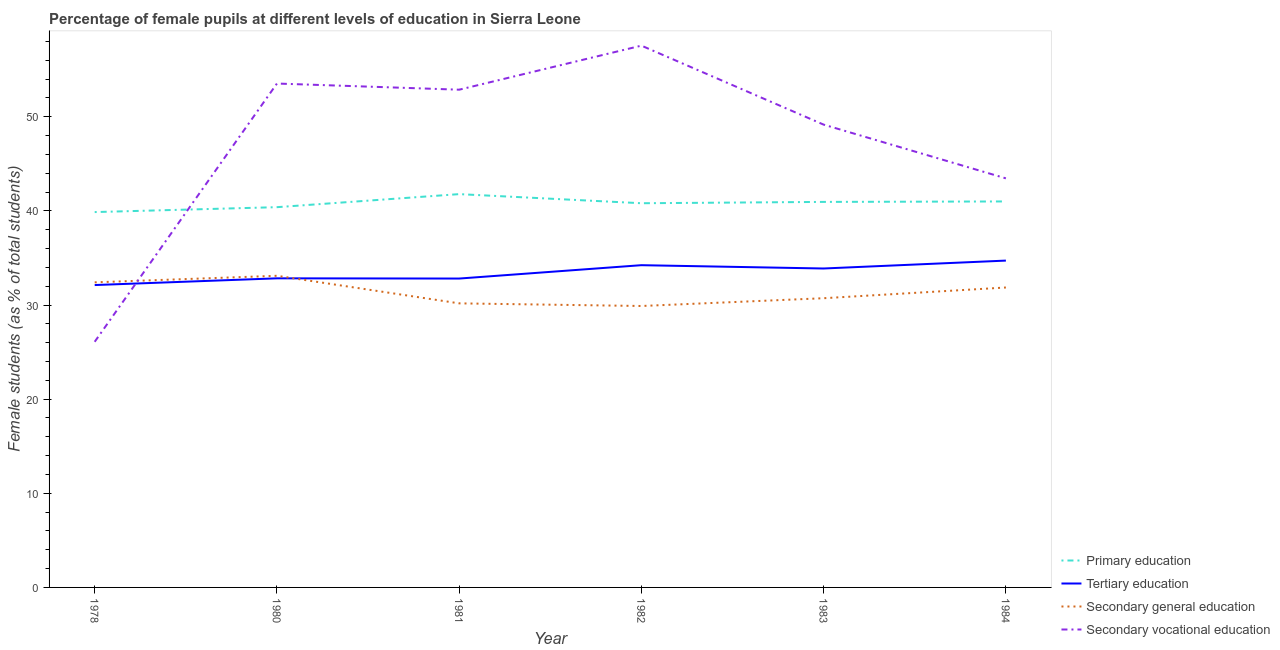Is the number of lines equal to the number of legend labels?
Make the answer very short. Yes. What is the percentage of female students in tertiary education in 1978?
Ensure brevity in your answer.  32.12. Across all years, what is the maximum percentage of female students in primary education?
Your answer should be very brief. 41.78. Across all years, what is the minimum percentage of female students in secondary vocational education?
Provide a succinct answer. 26.09. In which year was the percentage of female students in primary education minimum?
Your answer should be compact. 1978. What is the total percentage of female students in tertiary education in the graph?
Give a very brief answer. 200.59. What is the difference between the percentage of female students in primary education in 1978 and that in 1984?
Keep it short and to the point. -1.13. What is the difference between the percentage of female students in primary education in 1981 and the percentage of female students in tertiary education in 1980?
Provide a short and direct response. 8.95. What is the average percentage of female students in secondary vocational education per year?
Offer a very short reply. 47.11. In the year 1984, what is the difference between the percentage of female students in secondary education and percentage of female students in tertiary education?
Your answer should be compact. -2.86. What is the ratio of the percentage of female students in primary education in 1982 to that in 1983?
Your answer should be very brief. 1. What is the difference between the highest and the second highest percentage of female students in tertiary education?
Offer a terse response. 0.49. What is the difference between the highest and the lowest percentage of female students in secondary vocational education?
Your answer should be compact. 31.46. In how many years, is the percentage of female students in secondary vocational education greater than the average percentage of female students in secondary vocational education taken over all years?
Keep it short and to the point. 4. Is the sum of the percentage of female students in tertiary education in 1978 and 1982 greater than the maximum percentage of female students in primary education across all years?
Provide a succinct answer. Yes. Is the percentage of female students in primary education strictly less than the percentage of female students in tertiary education over the years?
Ensure brevity in your answer.  No. Does the graph contain grids?
Provide a short and direct response. No. How many legend labels are there?
Provide a short and direct response. 4. How are the legend labels stacked?
Your answer should be very brief. Vertical. What is the title of the graph?
Keep it short and to the point. Percentage of female pupils at different levels of education in Sierra Leone. What is the label or title of the X-axis?
Your response must be concise. Year. What is the label or title of the Y-axis?
Offer a terse response. Female students (as % of total students). What is the Female students (as % of total students) of Primary education in 1978?
Provide a short and direct response. 39.87. What is the Female students (as % of total students) in Tertiary education in 1978?
Provide a short and direct response. 32.12. What is the Female students (as % of total students) of Secondary general education in 1978?
Provide a succinct answer. 32.41. What is the Female students (as % of total students) of Secondary vocational education in 1978?
Offer a terse response. 26.09. What is the Female students (as % of total students) of Primary education in 1980?
Keep it short and to the point. 40.39. What is the Female students (as % of total students) in Tertiary education in 1980?
Your answer should be compact. 32.83. What is the Female students (as % of total students) of Secondary general education in 1980?
Provide a succinct answer. 33.1. What is the Female students (as % of total students) in Secondary vocational education in 1980?
Make the answer very short. 53.52. What is the Female students (as % of total students) in Primary education in 1981?
Make the answer very short. 41.78. What is the Female students (as % of total students) of Tertiary education in 1981?
Provide a succinct answer. 32.81. What is the Female students (as % of total students) in Secondary general education in 1981?
Provide a short and direct response. 30.17. What is the Female students (as % of total students) of Secondary vocational education in 1981?
Your response must be concise. 52.87. What is the Female students (as % of total students) in Primary education in 1982?
Provide a succinct answer. 40.81. What is the Female students (as % of total students) in Tertiary education in 1982?
Ensure brevity in your answer.  34.23. What is the Female students (as % of total students) in Secondary general education in 1982?
Offer a terse response. 29.89. What is the Female students (as % of total students) of Secondary vocational education in 1982?
Your response must be concise. 57.55. What is the Female students (as % of total students) of Primary education in 1983?
Provide a short and direct response. 40.95. What is the Female students (as % of total students) of Tertiary education in 1983?
Offer a very short reply. 33.88. What is the Female students (as % of total students) in Secondary general education in 1983?
Your answer should be very brief. 30.72. What is the Female students (as % of total students) of Secondary vocational education in 1983?
Provide a succinct answer. 49.16. What is the Female students (as % of total students) in Primary education in 1984?
Keep it short and to the point. 41. What is the Female students (as % of total students) in Tertiary education in 1984?
Keep it short and to the point. 34.72. What is the Female students (as % of total students) in Secondary general education in 1984?
Provide a short and direct response. 31.86. What is the Female students (as % of total students) in Secondary vocational education in 1984?
Keep it short and to the point. 43.45. Across all years, what is the maximum Female students (as % of total students) in Primary education?
Your answer should be compact. 41.78. Across all years, what is the maximum Female students (as % of total students) in Tertiary education?
Offer a very short reply. 34.72. Across all years, what is the maximum Female students (as % of total students) of Secondary general education?
Keep it short and to the point. 33.1. Across all years, what is the maximum Female students (as % of total students) in Secondary vocational education?
Your response must be concise. 57.55. Across all years, what is the minimum Female students (as % of total students) in Primary education?
Keep it short and to the point. 39.87. Across all years, what is the minimum Female students (as % of total students) of Tertiary education?
Your response must be concise. 32.12. Across all years, what is the minimum Female students (as % of total students) of Secondary general education?
Ensure brevity in your answer.  29.89. Across all years, what is the minimum Female students (as % of total students) of Secondary vocational education?
Make the answer very short. 26.09. What is the total Female students (as % of total students) in Primary education in the graph?
Keep it short and to the point. 244.8. What is the total Female students (as % of total students) in Tertiary education in the graph?
Your answer should be compact. 200.59. What is the total Female students (as % of total students) in Secondary general education in the graph?
Your answer should be very brief. 188.16. What is the total Female students (as % of total students) of Secondary vocational education in the graph?
Ensure brevity in your answer.  282.65. What is the difference between the Female students (as % of total students) in Primary education in 1978 and that in 1980?
Provide a short and direct response. -0.52. What is the difference between the Female students (as % of total students) in Tertiary education in 1978 and that in 1980?
Your response must be concise. -0.71. What is the difference between the Female students (as % of total students) of Secondary general education in 1978 and that in 1980?
Ensure brevity in your answer.  -0.7. What is the difference between the Female students (as % of total students) of Secondary vocational education in 1978 and that in 1980?
Ensure brevity in your answer.  -27.43. What is the difference between the Female students (as % of total students) of Primary education in 1978 and that in 1981?
Provide a succinct answer. -1.91. What is the difference between the Female students (as % of total students) of Tertiary education in 1978 and that in 1981?
Your response must be concise. -0.69. What is the difference between the Female students (as % of total students) in Secondary general education in 1978 and that in 1981?
Ensure brevity in your answer.  2.23. What is the difference between the Female students (as % of total students) of Secondary vocational education in 1978 and that in 1981?
Keep it short and to the point. -26.78. What is the difference between the Female students (as % of total students) of Primary education in 1978 and that in 1982?
Offer a terse response. -0.94. What is the difference between the Female students (as % of total students) in Tertiary education in 1978 and that in 1982?
Provide a short and direct response. -2.11. What is the difference between the Female students (as % of total students) of Secondary general education in 1978 and that in 1982?
Offer a very short reply. 2.51. What is the difference between the Female students (as % of total students) in Secondary vocational education in 1978 and that in 1982?
Your answer should be compact. -31.46. What is the difference between the Female students (as % of total students) of Primary education in 1978 and that in 1983?
Your response must be concise. -1.08. What is the difference between the Female students (as % of total students) of Tertiary education in 1978 and that in 1983?
Ensure brevity in your answer.  -1.76. What is the difference between the Female students (as % of total students) in Secondary general education in 1978 and that in 1983?
Give a very brief answer. 1.69. What is the difference between the Female students (as % of total students) of Secondary vocational education in 1978 and that in 1983?
Make the answer very short. -23.07. What is the difference between the Female students (as % of total students) of Primary education in 1978 and that in 1984?
Offer a very short reply. -1.13. What is the difference between the Female students (as % of total students) in Tertiary education in 1978 and that in 1984?
Keep it short and to the point. -2.6. What is the difference between the Female students (as % of total students) of Secondary general education in 1978 and that in 1984?
Your answer should be compact. 0.55. What is the difference between the Female students (as % of total students) in Secondary vocational education in 1978 and that in 1984?
Ensure brevity in your answer.  -17.36. What is the difference between the Female students (as % of total students) of Primary education in 1980 and that in 1981?
Give a very brief answer. -1.39. What is the difference between the Female students (as % of total students) in Tertiary education in 1980 and that in 1981?
Give a very brief answer. 0.02. What is the difference between the Female students (as % of total students) in Secondary general education in 1980 and that in 1981?
Your answer should be compact. 2.93. What is the difference between the Female students (as % of total students) of Secondary vocational education in 1980 and that in 1981?
Ensure brevity in your answer.  0.65. What is the difference between the Female students (as % of total students) of Primary education in 1980 and that in 1982?
Give a very brief answer. -0.42. What is the difference between the Female students (as % of total students) of Tertiary education in 1980 and that in 1982?
Provide a short and direct response. -1.4. What is the difference between the Female students (as % of total students) in Secondary general education in 1980 and that in 1982?
Your response must be concise. 3.21. What is the difference between the Female students (as % of total students) of Secondary vocational education in 1980 and that in 1982?
Offer a very short reply. -4.03. What is the difference between the Female students (as % of total students) in Primary education in 1980 and that in 1983?
Offer a very short reply. -0.56. What is the difference between the Female students (as % of total students) in Tertiary education in 1980 and that in 1983?
Offer a terse response. -1.05. What is the difference between the Female students (as % of total students) in Secondary general education in 1980 and that in 1983?
Keep it short and to the point. 2.38. What is the difference between the Female students (as % of total students) in Secondary vocational education in 1980 and that in 1983?
Your response must be concise. 4.37. What is the difference between the Female students (as % of total students) in Primary education in 1980 and that in 1984?
Give a very brief answer. -0.61. What is the difference between the Female students (as % of total students) of Tertiary education in 1980 and that in 1984?
Provide a short and direct response. -1.88. What is the difference between the Female students (as % of total students) in Secondary general education in 1980 and that in 1984?
Offer a terse response. 1.24. What is the difference between the Female students (as % of total students) of Secondary vocational education in 1980 and that in 1984?
Give a very brief answer. 10.07. What is the difference between the Female students (as % of total students) in Primary education in 1981 and that in 1982?
Provide a succinct answer. 0.97. What is the difference between the Female students (as % of total students) of Tertiary education in 1981 and that in 1982?
Your answer should be very brief. -1.42. What is the difference between the Female students (as % of total students) of Secondary general education in 1981 and that in 1982?
Provide a short and direct response. 0.28. What is the difference between the Female students (as % of total students) in Secondary vocational education in 1981 and that in 1982?
Your answer should be compact. -4.68. What is the difference between the Female students (as % of total students) in Primary education in 1981 and that in 1983?
Your answer should be compact. 0.83. What is the difference between the Female students (as % of total students) in Tertiary education in 1981 and that in 1983?
Your answer should be very brief. -1.07. What is the difference between the Female students (as % of total students) in Secondary general education in 1981 and that in 1983?
Offer a very short reply. -0.55. What is the difference between the Female students (as % of total students) of Secondary vocational education in 1981 and that in 1983?
Offer a very short reply. 3.71. What is the difference between the Female students (as % of total students) of Primary education in 1981 and that in 1984?
Your answer should be compact. 0.78. What is the difference between the Female students (as % of total students) in Tertiary education in 1981 and that in 1984?
Your answer should be compact. -1.91. What is the difference between the Female students (as % of total students) of Secondary general education in 1981 and that in 1984?
Your response must be concise. -1.68. What is the difference between the Female students (as % of total students) of Secondary vocational education in 1981 and that in 1984?
Offer a terse response. 9.42. What is the difference between the Female students (as % of total students) of Primary education in 1982 and that in 1983?
Provide a short and direct response. -0.14. What is the difference between the Female students (as % of total students) in Tertiary education in 1982 and that in 1983?
Your response must be concise. 0.35. What is the difference between the Female students (as % of total students) of Secondary general education in 1982 and that in 1983?
Keep it short and to the point. -0.83. What is the difference between the Female students (as % of total students) of Secondary vocational education in 1982 and that in 1983?
Provide a short and direct response. 8.39. What is the difference between the Female students (as % of total students) in Primary education in 1982 and that in 1984?
Offer a terse response. -0.19. What is the difference between the Female students (as % of total students) of Tertiary education in 1982 and that in 1984?
Your answer should be compact. -0.49. What is the difference between the Female students (as % of total students) of Secondary general education in 1982 and that in 1984?
Provide a succinct answer. -1.97. What is the difference between the Female students (as % of total students) in Secondary vocational education in 1982 and that in 1984?
Provide a succinct answer. 14.1. What is the difference between the Female students (as % of total students) in Primary education in 1983 and that in 1984?
Offer a very short reply. -0.05. What is the difference between the Female students (as % of total students) in Tertiary education in 1983 and that in 1984?
Your answer should be very brief. -0.84. What is the difference between the Female students (as % of total students) of Secondary general education in 1983 and that in 1984?
Make the answer very short. -1.14. What is the difference between the Female students (as % of total students) of Secondary vocational education in 1983 and that in 1984?
Offer a terse response. 5.71. What is the difference between the Female students (as % of total students) in Primary education in 1978 and the Female students (as % of total students) in Tertiary education in 1980?
Provide a short and direct response. 7.04. What is the difference between the Female students (as % of total students) in Primary education in 1978 and the Female students (as % of total students) in Secondary general education in 1980?
Your response must be concise. 6.77. What is the difference between the Female students (as % of total students) of Primary education in 1978 and the Female students (as % of total students) of Secondary vocational education in 1980?
Provide a succinct answer. -13.65. What is the difference between the Female students (as % of total students) of Tertiary education in 1978 and the Female students (as % of total students) of Secondary general education in 1980?
Your response must be concise. -0.98. What is the difference between the Female students (as % of total students) in Tertiary education in 1978 and the Female students (as % of total students) in Secondary vocational education in 1980?
Give a very brief answer. -21.41. What is the difference between the Female students (as % of total students) of Secondary general education in 1978 and the Female students (as % of total students) of Secondary vocational education in 1980?
Ensure brevity in your answer.  -21.12. What is the difference between the Female students (as % of total students) of Primary education in 1978 and the Female students (as % of total students) of Tertiary education in 1981?
Your answer should be very brief. 7.06. What is the difference between the Female students (as % of total students) in Primary education in 1978 and the Female students (as % of total students) in Secondary general education in 1981?
Provide a short and direct response. 9.7. What is the difference between the Female students (as % of total students) in Primary education in 1978 and the Female students (as % of total students) in Secondary vocational education in 1981?
Your response must be concise. -13. What is the difference between the Female students (as % of total students) of Tertiary education in 1978 and the Female students (as % of total students) of Secondary general education in 1981?
Your answer should be compact. 1.94. What is the difference between the Female students (as % of total students) in Tertiary education in 1978 and the Female students (as % of total students) in Secondary vocational education in 1981?
Provide a short and direct response. -20.75. What is the difference between the Female students (as % of total students) of Secondary general education in 1978 and the Female students (as % of total students) of Secondary vocational education in 1981?
Make the answer very short. -20.46. What is the difference between the Female students (as % of total students) of Primary education in 1978 and the Female students (as % of total students) of Tertiary education in 1982?
Offer a very short reply. 5.64. What is the difference between the Female students (as % of total students) of Primary education in 1978 and the Female students (as % of total students) of Secondary general education in 1982?
Offer a very short reply. 9.98. What is the difference between the Female students (as % of total students) in Primary education in 1978 and the Female students (as % of total students) in Secondary vocational education in 1982?
Your answer should be compact. -17.68. What is the difference between the Female students (as % of total students) of Tertiary education in 1978 and the Female students (as % of total students) of Secondary general education in 1982?
Keep it short and to the point. 2.22. What is the difference between the Female students (as % of total students) in Tertiary education in 1978 and the Female students (as % of total students) in Secondary vocational education in 1982?
Make the answer very short. -25.43. What is the difference between the Female students (as % of total students) in Secondary general education in 1978 and the Female students (as % of total students) in Secondary vocational education in 1982?
Offer a very short reply. -25.14. What is the difference between the Female students (as % of total students) of Primary education in 1978 and the Female students (as % of total students) of Tertiary education in 1983?
Make the answer very short. 5.99. What is the difference between the Female students (as % of total students) of Primary education in 1978 and the Female students (as % of total students) of Secondary general education in 1983?
Provide a succinct answer. 9.15. What is the difference between the Female students (as % of total students) of Primary education in 1978 and the Female students (as % of total students) of Secondary vocational education in 1983?
Provide a short and direct response. -9.29. What is the difference between the Female students (as % of total students) of Tertiary education in 1978 and the Female students (as % of total students) of Secondary general education in 1983?
Give a very brief answer. 1.4. What is the difference between the Female students (as % of total students) in Tertiary education in 1978 and the Female students (as % of total students) in Secondary vocational education in 1983?
Offer a very short reply. -17.04. What is the difference between the Female students (as % of total students) of Secondary general education in 1978 and the Female students (as % of total students) of Secondary vocational education in 1983?
Provide a short and direct response. -16.75. What is the difference between the Female students (as % of total students) in Primary education in 1978 and the Female students (as % of total students) in Tertiary education in 1984?
Offer a very short reply. 5.15. What is the difference between the Female students (as % of total students) in Primary education in 1978 and the Female students (as % of total students) in Secondary general education in 1984?
Make the answer very short. 8.01. What is the difference between the Female students (as % of total students) in Primary education in 1978 and the Female students (as % of total students) in Secondary vocational education in 1984?
Your response must be concise. -3.58. What is the difference between the Female students (as % of total students) in Tertiary education in 1978 and the Female students (as % of total students) in Secondary general education in 1984?
Provide a short and direct response. 0.26. What is the difference between the Female students (as % of total students) of Tertiary education in 1978 and the Female students (as % of total students) of Secondary vocational education in 1984?
Your answer should be very brief. -11.33. What is the difference between the Female students (as % of total students) in Secondary general education in 1978 and the Female students (as % of total students) in Secondary vocational education in 1984?
Ensure brevity in your answer.  -11.04. What is the difference between the Female students (as % of total students) in Primary education in 1980 and the Female students (as % of total students) in Tertiary education in 1981?
Offer a very short reply. 7.58. What is the difference between the Female students (as % of total students) in Primary education in 1980 and the Female students (as % of total students) in Secondary general education in 1981?
Offer a terse response. 10.22. What is the difference between the Female students (as % of total students) in Primary education in 1980 and the Female students (as % of total students) in Secondary vocational education in 1981?
Your response must be concise. -12.48. What is the difference between the Female students (as % of total students) in Tertiary education in 1980 and the Female students (as % of total students) in Secondary general education in 1981?
Your response must be concise. 2.66. What is the difference between the Female students (as % of total students) of Tertiary education in 1980 and the Female students (as % of total students) of Secondary vocational education in 1981?
Your answer should be very brief. -20.04. What is the difference between the Female students (as % of total students) in Secondary general education in 1980 and the Female students (as % of total students) in Secondary vocational education in 1981?
Give a very brief answer. -19.77. What is the difference between the Female students (as % of total students) of Primary education in 1980 and the Female students (as % of total students) of Tertiary education in 1982?
Offer a terse response. 6.16. What is the difference between the Female students (as % of total students) of Primary education in 1980 and the Female students (as % of total students) of Secondary general education in 1982?
Ensure brevity in your answer.  10.5. What is the difference between the Female students (as % of total students) in Primary education in 1980 and the Female students (as % of total students) in Secondary vocational education in 1982?
Keep it short and to the point. -17.16. What is the difference between the Female students (as % of total students) in Tertiary education in 1980 and the Female students (as % of total students) in Secondary general education in 1982?
Ensure brevity in your answer.  2.94. What is the difference between the Female students (as % of total students) of Tertiary education in 1980 and the Female students (as % of total students) of Secondary vocational education in 1982?
Your response must be concise. -24.72. What is the difference between the Female students (as % of total students) of Secondary general education in 1980 and the Female students (as % of total students) of Secondary vocational education in 1982?
Ensure brevity in your answer.  -24.45. What is the difference between the Female students (as % of total students) in Primary education in 1980 and the Female students (as % of total students) in Tertiary education in 1983?
Your answer should be very brief. 6.51. What is the difference between the Female students (as % of total students) in Primary education in 1980 and the Female students (as % of total students) in Secondary general education in 1983?
Offer a very short reply. 9.67. What is the difference between the Female students (as % of total students) in Primary education in 1980 and the Female students (as % of total students) in Secondary vocational education in 1983?
Your answer should be compact. -8.77. What is the difference between the Female students (as % of total students) in Tertiary education in 1980 and the Female students (as % of total students) in Secondary general education in 1983?
Give a very brief answer. 2.11. What is the difference between the Female students (as % of total students) in Tertiary education in 1980 and the Female students (as % of total students) in Secondary vocational education in 1983?
Keep it short and to the point. -16.33. What is the difference between the Female students (as % of total students) of Secondary general education in 1980 and the Female students (as % of total students) of Secondary vocational education in 1983?
Provide a short and direct response. -16.06. What is the difference between the Female students (as % of total students) in Primary education in 1980 and the Female students (as % of total students) in Tertiary education in 1984?
Provide a short and direct response. 5.67. What is the difference between the Female students (as % of total students) in Primary education in 1980 and the Female students (as % of total students) in Secondary general education in 1984?
Your response must be concise. 8.53. What is the difference between the Female students (as % of total students) of Primary education in 1980 and the Female students (as % of total students) of Secondary vocational education in 1984?
Your response must be concise. -3.06. What is the difference between the Female students (as % of total students) in Tertiary education in 1980 and the Female students (as % of total students) in Secondary general education in 1984?
Your answer should be compact. 0.97. What is the difference between the Female students (as % of total students) of Tertiary education in 1980 and the Female students (as % of total students) of Secondary vocational education in 1984?
Make the answer very short. -10.62. What is the difference between the Female students (as % of total students) in Secondary general education in 1980 and the Female students (as % of total students) in Secondary vocational education in 1984?
Offer a very short reply. -10.35. What is the difference between the Female students (as % of total students) in Primary education in 1981 and the Female students (as % of total students) in Tertiary education in 1982?
Your response must be concise. 7.55. What is the difference between the Female students (as % of total students) in Primary education in 1981 and the Female students (as % of total students) in Secondary general education in 1982?
Provide a succinct answer. 11.88. What is the difference between the Female students (as % of total students) in Primary education in 1981 and the Female students (as % of total students) in Secondary vocational education in 1982?
Your answer should be very brief. -15.77. What is the difference between the Female students (as % of total students) of Tertiary education in 1981 and the Female students (as % of total students) of Secondary general education in 1982?
Keep it short and to the point. 2.92. What is the difference between the Female students (as % of total students) in Tertiary education in 1981 and the Female students (as % of total students) in Secondary vocational education in 1982?
Ensure brevity in your answer.  -24.74. What is the difference between the Female students (as % of total students) of Secondary general education in 1981 and the Female students (as % of total students) of Secondary vocational education in 1982?
Offer a terse response. -27.38. What is the difference between the Female students (as % of total students) of Primary education in 1981 and the Female students (as % of total students) of Tertiary education in 1983?
Provide a succinct answer. 7.9. What is the difference between the Female students (as % of total students) in Primary education in 1981 and the Female students (as % of total students) in Secondary general education in 1983?
Your answer should be very brief. 11.06. What is the difference between the Female students (as % of total students) of Primary education in 1981 and the Female students (as % of total students) of Secondary vocational education in 1983?
Offer a terse response. -7.38. What is the difference between the Female students (as % of total students) in Tertiary education in 1981 and the Female students (as % of total students) in Secondary general education in 1983?
Give a very brief answer. 2.09. What is the difference between the Female students (as % of total students) in Tertiary education in 1981 and the Female students (as % of total students) in Secondary vocational education in 1983?
Your answer should be very brief. -16.35. What is the difference between the Female students (as % of total students) in Secondary general education in 1981 and the Female students (as % of total students) in Secondary vocational education in 1983?
Ensure brevity in your answer.  -18.98. What is the difference between the Female students (as % of total students) of Primary education in 1981 and the Female students (as % of total students) of Tertiary education in 1984?
Provide a succinct answer. 7.06. What is the difference between the Female students (as % of total students) of Primary education in 1981 and the Female students (as % of total students) of Secondary general education in 1984?
Provide a succinct answer. 9.92. What is the difference between the Female students (as % of total students) of Primary education in 1981 and the Female students (as % of total students) of Secondary vocational education in 1984?
Your answer should be compact. -1.67. What is the difference between the Female students (as % of total students) of Tertiary education in 1981 and the Female students (as % of total students) of Secondary vocational education in 1984?
Keep it short and to the point. -10.64. What is the difference between the Female students (as % of total students) in Secondary general education in 1981 and the Female students (as % of total students) in Secondary vocational education in 1984?
Give a very brief answer. -13.28. What is the difference between the Female students (as % of total students) in Primary education in 1982 and the Female students (as % of total students) in Tertiary education in 1983?
Keep it short and to the point. 6.93. What is the difference between the Female students (as % of total students) of Primary education in 1982 and the Female students (as % of total students) of Secondary general education in 1983?
Offer a terse response. 10.09. What is the difference between the Female students (as % of total students) of Primary education in 1982 and the Female students (as % of total students) of Secondary vocational education in 1983?
Provide a succinct answer. -8.35. What is the difference between the Female students (as % of total students) in Tertiary education in 1982 and the Female students (as % of total students) in Secondary general education in 1983?
Provide a succinct answer. 3.51. What is the difference between the Female students (as % of total students) in Tertiary education in 1982 and the Female students (as % of total students) in Secondary vocational education in 1983?
Keep it short and to the point. -14.93. What is the difference between the Female students (as % of total students) of Secondary general education in 1982 and the Female students (as % of total students) of Secondary vocational education in 1983?
Your response must be concise. -19.26. What is the difference between the Female students (as % of total students) of Primary education in 1982 and the Female students (as % of total students) of Tertiary education in 1984?
Provide a short and direct response. 6.09. What is the difference between the Female students (as % of total students) of Primary education in 1982 and the Female students (as % of total students) of Secondary general education in 1984?
Offer a terse response. 8.95. What is the difference between the Female students (as % of total students) of Primary education in 1982 and the Female students (as % of total students) of Secondary vocational education in 1984?
Provide a short and direct response. -2.64. What is the difference between the Female students (as % of total students) of Tertiary education in 1982 and the Female students (as % of total students) of Secondary general education in 1984?
Keep it short and to the point. 2.37. What is the difference between the Female students (as % of total students) of Tertiary education in 1982 and the Female students (as % of total students) of Secondary vocational education in 1984?
Offer a very short reply. -9.22. What is the difference between the Female students (as % of total students) of Secondary general education in 1982 and the Female students (as % of total students) of Secondary vocational education in 1984?
Offer a very short reply. -13.56. What is the difference between the Female students (as % of total students) of Primary education in 1983 and the Female students (as % of total students) of Tertiary education in 1984?
Provide a succinct answer. 6.23. What is the difference between the Female students (as % of total students) of Primary education in 1983 and the Female students (as % of total students) of Secondary general education in 1984?
Keep it short and to the point. 9.09. What is the difference between the Female students (as % of total students) in Primary education in 1983 and the Female students (as % of total students) in Secondary vocational education in 1984?
Keep it short and to the point. -2.5. What is the difference between the Female students (as % of total students) in Tertiary education in 1983 and the Female students (as % of total students) in Secondary general education in 1984?
Your response must be concise. 2.02. What is the difference between the Female students (as % of total students) of Tertiary education in 1983 and the Female students (as % of total students) of Secondary vocational education in 1984?
Ensure brevity in your answer.  -9.57. What is the difference between the Female students (as % of total students) of Secondary general education in 1983 and the Female students (as % of total students) of Secondary vocational education in 1984?
Provide a succinct answer. -12.73. What is the average Female students (as % of total students) of Primary education per year?
Ensure brevity in your answer.  40.8. What is the average Female students (as % of total students) of Tertiary education per year?
Provide a succinct answer. 33.43. What is the average Female students (as % of total students) of Secondary general education per year?
Your response must be concise. 31.36. What is the average Female students (as % of total students) of Secondary vocational education per year?
Ensure brevity in your answer.  47.11. In the year 1978, what is the difference between the Female students (as % of total students) of Primary education and Female students (as % of total students) of Tertiary education?
Your response must be concise. 7.75. In the year 1978, what is the difference between the Female students (as % of total students) in Primary education and Female students (as % of total students) in Secondary general education?
Provide a succinct answer. 7.46. In the year 1978, what is the difference between the Female students (as % of total students) in Primary education and Female students (as % of total students) in Secondary vocational education?
Give a very brief answer. 13.78. In the year 1978, what is the difference between the Female students (as % of total students) of Tertiary education and Female students (as % of total students) of Secondary general education?
Your answer should be very brief. -0.29. In the year 1978, what is the difference between the Female students (as % of total students) of Tertiary education and Female students (as % of total students) of Secondary vocational education?
Ensure brevity in your answer.  6.03. In the year 1978, what is the difference between the Female students (as % of total students) of Secondary general education and Female students (as % of total students) of Secondary vocational education?
Give a very brief answer. 6.31. In the year 1980, what is the difference between the Female students (as % of total students) in Primary education and Female students (as % of total students) in Tertiary education?
Make the answer very short. 7.56. In the year 1980, what is the difference between the Female students (as % of total students) in Primary education and Female students (as % of total students) in Secondary general education?
Provide a succinct answer. 7.29. In the year 1980, what is the difference between the Female students (as % of total students) of Primary education and Female students (as % of total students) of Secondary vocational education?
Ensure brevity in your answer.  -13.13. In the year 1980, what is the difference between the Female students (as % of total students) in Tertiary education and Female students (as % of total students) in Secondary general education?
Offer a very short reply. -0.27. In the year 1980, what is the difference between the Female students (as % of total students) of Tertiary education and Female students (as % of total students) of Secondary vocational education?
Provide a succinct answer. -20.69. In the year 1980, what is the difference between the Female students (as % of total students) of Secondary general education and Female students (as % of total students) of Secondary vocational education?
Provide a succinct answer. -20.42. In the year 1981, what is the difference between the Female students (as % of total students) of Primary education and Female students (as % of total students) of Tertiary education?
Provide a succinct answer. 8.97. In the year 1981, what is the difference between the Female students (as % of total students) in Primary education and Female students (as % of total students) in Secondary general education?
Keep it short and to the point. 11.6. In the year 1981, what is the difference between the Female students (as % of total students) of Primary education and Female students (as % of total students) of Secondary vocational education?
Your answer should be compact. -11.09. In the year 1981, what is the difference between the Female students (as % of total students) in Tertiary education and Female students (as % of total students) in Secondary general education?
Provide a succinct answer. 2.63. In the year 1981, what is the difference between the Female students (as % of total students) of Tertiary education and Female students (as % of total students) of Secondary vocational education?
Make the answer very short. -20.06. In the year 1981, what is the difference between the Female students (as % of total students) of Secondary general education and Female students (as % of total students) of Secondary vocational education?
Make the answer very short. -22.7. In the year 1982, what is the difference between the Female students (as % of total students) in Primary education and Female students (as % of total students) in Tertiary education?
Your answer should be very brief. 6.58. In the year 1982, what is the difference between the Female students (as % of total students) of Primary education and Female students (as % of total students) of Secondary general education?
Keep it short and to the point. 10.92. In the year 1982, what is the difference between the Female students (as % of total students) of Primary education and Female students (as % of total students) of Secondary vocational education?
Your answer should be very brief. -16.74. In the year 1982, what is the difference between the Female students (as % of total students) of Tertiary education and Female students (as % of total students) of Secondary general education?
Ensure brevity in your answer.  4.34. In the year 1982, what is the difference between the Female students (as % of total students) in Tertiary education and Female students (as % of total students) in Secondary vocational education?
Provide a short and direct response. -23.32. In the year 1982, what is the difference between the Female students (as % of total students) of Secondary general education and Female students (as % of total students) of Secondary vocational education?
Provide a short and direct response. -27.66. In the year 1983, what is the difference between the Female students (as % of total students) of Primary education and Female students (as % of total students) of Tertiary education?
Ensure brevity in your answer.  7.07. In the year 1983, what is the difference between the Female students (as % of total students) in Primary education and Female students (as % of total students) in Secondary general education?
Provide a short and direct response. 10.23. In the year 1983, what is the difference between the Female students (as % of total students) of Primary education and Female students (as % of total students) of Secondary vocational education?
Keep it short and to the point. -8.21. In the year 1983, what is the difference between the Female students (as % of total students) in Tertiary education and Female students (as % of total students) in Secondary general education?
Your response must be concise. 3.16. In the year 1983, what is the difference between the Female students (as % of total students) in Tertiary education and Female students (as % of total students) in Secondary vocational education?
Provide a succinct answer. -15.28. In the year 1983, what is the difference between the Female students (as % of total students) of Secondary general education and Female students (as % of total students) of Secondary vocational education?
Your response must be concise. -18.44. In the year 1984, what is the difference between the Female students (as % of total students) of Primary education and Female students (as % of total students) of Tertiary education?
Offer a very short reply. 6.28. In the year 1984, what is the difference between the Female students (as % of total students) in Primary education and Female students (as % of total students) in Secondary general education?
Ensure brevity in your answer.  9.14. In the year 1984, what is the difference between the Female students (as % of total students) in Primary education and Female students (as % of total students) in Secondary vocational education?
Provide a succinct answer. -2.45. In the year 1984, what is the difference between the Female students (as % of total students) in Tertiary education and Female students (as % of total students) in Secondary general education?
Make the answer very short. 2.86. In the year 1984, what is the difference between the Female students (as % of total students) in Tertiary education and Female students (as % of total students) in Secondary vocational education?
Provide a succinct answer. -8.73. In the year 1984, what is the difference between the Female students (as % of total students) in Secondary general education and Female students (as % of total students) in Secondary vocational education?
Ensure brevity in your answer.  -11.59. What is the ratio of the Female students (as % of total students) in Primary education in 1978 to that in 1980?
Keep it short and to the point. 0.99. What is the ratio of the Female students (as % of total students) in Tertiary education in 1978 to that in 1980?
Offer a very short reply. 0.98. What is the ratio of the Female students (as % of total students) of Secondary vocational education in 1978 to that in 1980?
Offer a very short reply. 0.49. What is the ratio of the Female students (as % of total students) in Primary education in 1978 to that in 1981?
Your response must be concise. 0.95. What is the ratio of the Female students (as % of total students) of Secondary general education in 1978 to that in 1981?
Offer a very short reply. 1.07. What is the ratio of the Female students (as % of total students) of Secondary vocational education in 1978 to that in 1981?
Offer a very short reply. 0.49. What is the ratio of the Female students (as % of total students) in Tertiary education in 1978 to that in 1982?
Your answer should be very brief. 0.94. What is the ratio of the Female students (as % of total students) in Secondary general education in 1978 to that in 1982?
Provide a succinct answer. 1.08. What is the ratio of the Female students (as % of total students) in Secondary vocational education in 1978 to that in 1982?
Your answer should be compact. 0.45. What is the ratio of the Female students (as % of total students) of Primary education in 1978 to that in 1983?
Offer a very short reply. 0.97. What is the ratio of the Female students (as % of total students) of Tertiary education in 1978 to that in 1983?
Your answer should be very brief. 0.95. What is the ratio of the Female students (as % of total students) in Secondary general education in 1978 to that in 1983?
Provide a succinct answer. 1.05. What is the ratio of the Female students (as % of total students) of Secondary vocational education in 1978 to that in 1983?
Your response must be concise. 0.53. What is the ratio of the Female students (as % of total students) in Primary education in 1978 to that in 1984?
Provide a succinct answer. 0.97. What is the ratio of the Female students (as % of total students) in Tertiary education in 1978 to that in 1984?
Your response must be concise. 0.93. What is the ratio of the Female students (as % of total students) in Secondary general education in 1978 to that in 1984?
Keep it short and to the point. 1.02. What is the ratio of the Female students (as % of total students) of Secondary vocational education in 1978 to that in 1984?
Your answer should be compact. 0.6. What is the ratio of the Female students (as % of total students) in Primary education in 1980 to that in 1981?
Your answer should be compact. 0.97. What is the ratio of the Female students (as % of total students) of Secondary general education in 1980 to that in 1981?
Offer a terse response. 1.1. What is the ratio of the Female students (as % of total students) of Secondary vocational education in 1980 to that in 1981?
Offer a terse response. 1.01. What is the ratio of the Female students (as % of total students) of Primary education in 1980 to that in 1982?
Your response must be concise. 0.99. What is the ratio of the Female students (as % of total students) of Tertiary education in 1980 to that in 1982?
Your answer should be compact. 0.96. What is the ratio of the Female students (as % of total students) in Secondary general education in 1980 to that in 1982?
Ensure brevity in your answer.  1.11. What is the ratio of the Female students (as % of total students) of Primary education in 1980 to that in 1983?
Offer a very short reply. 0.99. What is the ratio of the Female students (as % of total students) in Tertiary education in 1980 to that in 1983?
Your response must be concise. 0.97. What is the ratio of the Female students (as % of total students) in Secondary general education in 1980 to that in 1983?
Give a very brief answer. 1.08. What is the ratio of the Female students (as % of total students) in Secondary vocational education in 1980 to that in 1983?
Your response must be concise. 1.09. What is the ratio of the Female students (as % of total students) in Primary education in 1980 to that in 1984?
Offer a terse response. 0.99. What is the ratio of the Female students (as % of total students) in Tertiary education in 1980 to that in 1984?
Give a very brief answer. 0.95. What is the ratio of the Female students (as % of total students) in Secondary general education in 1980 to that in 1984?
Your response must be concise. 1.04. What is the ratio of the Female students (as % of total students) of Secondary vocational education in 1980 to that in 1984?
Provide a short and direct response. 1.23. What is the ratio of the Female students (as % of total students) of Primary education in 1981 to that in 1982?
Your answer should be compact. 1.02. What is the ratio of the Female students (as % of total students) of Tertiary education in 1981 to that in 1982?
Your answer should be compact. 0.96. What is the ratio of the Female students (as % of total students) in Secondary general education in 1981 to that in 1982?
Your answer should be compact. 1.01. What is the ratio of the Female students (as % of total students) in Secondary vocational education in 1981 to that in 1982?
Your response must be concise. 0.92. What is the ratio of the Female students (as % of total students) in Primary education in 1981 to that in 1983?
Your answer should be compact. 1.02. What is the ratio of the Female students (as % of total students) in Tertiary education in 1981 to that in 1983?
Make the answer very short. 0.97. What is the ratio of the Female students (as % of total students) in Secondary general education in 1981 to that in 1983?
Your answer should be compact. 0.98. What is the ratio of the Female students (as % of total students) of Secondary vocational education in 1981 to that in 1983?
Your answer should be compact. 1.08. What is the ratio of the Female students (as % of total students) in Primary education in 1981 to that in 1984?
Your response must be concise. 1.02. What is the ratio of the Female students (as % of total students) of Tertiary education in 1981 to that in 1984?
Keep it short and to the point. 0.94. What is the ratio of the Female students (as % of total students) in Secondary general education in 1981 to that in 1984?
Keep it short and to the point. 0.95. What is the ratio of the Female students (as % of total students) of Secondary vocational education in 1981 to that in 1984?
Your answer should be compact. 1.22. What is the ratio of the Female students (as % of total students) of Tertiary education in 1982 to that in 1983?
Give a very brief answer. 1.01. What is the ratio of the Female students (as % of total students) of Secondary general education in 1982 to that in 1983?
Offer a very short reply. 0.97. What is the ratio of the Female students (as % of total students) of Secondary vocational education in 1982 to that in 1983?
Provide a short and direct response. 1.17. What is the ratio of the Female students (as % of total students) in Primary education in 1982 to that in 1984?
Offer a terse response. 1. What is the ratio of the Female students (as % of total students) of Secondary general education in 1982 to that in 1984?
Your answer should be compact. 0.94. What is the ratio of the Female students (as % of total students) of Secondary vocational education in 1982 to that in 1984?
Give a very brief answer. 1.32. What is the ratio of the Female students (as % of total students) in Primary education in 1983 to that in 1984?
Offer a very short reply. 1. What is the ratio of the Female students (as % of total students) in Tertiary education in 1983 to that in 1984?
Keep it short and to the point. 0.98. What is the ratio of the Female students (as % of total students) of Secondary general education in 1983 to that in 1984?
Keep it short and to the point. 0.96. What is the ratio of the Female students (as % of total students) of Secondary vocational education in 1983 to that in 1984?
Provide a short and direct response. 1.13. What is the difference between the highest and the second highest Female students (as % of total students) in Primary education?
Ensure brevity in your answer.  0.78. What is the difference between the highest and the second highest Female students (as % of total students) of Tertiary education?
Give a very brief answer. 0.49. What is the difference between the highest and the second highest Female students (as % of total students) of Secondary general education?
Provide a succinct answer. 0.7. What is the difference between the highest and the second highest Female students (as % of total students) in Secondary vocational education?
Offer a terse response. 4.03. What is the difference between the highest and the lowest Female students (as % of total students) of Primary education?
Provide a short and direct response. 1.91. What is the difference between the highest and the lowest Female students (as % of total students) of Tertiary education?
Offer a very short reply. 2.6. What is the difference between the highest and the lowest Female students (as % of total students) of Secondary general education?
Offer a terse response. 3.21. What is the difference between the highest and the lowest Female students (as % of total students) of Secondary vocational education?
Ensure brevity in your answer.  31.46. 